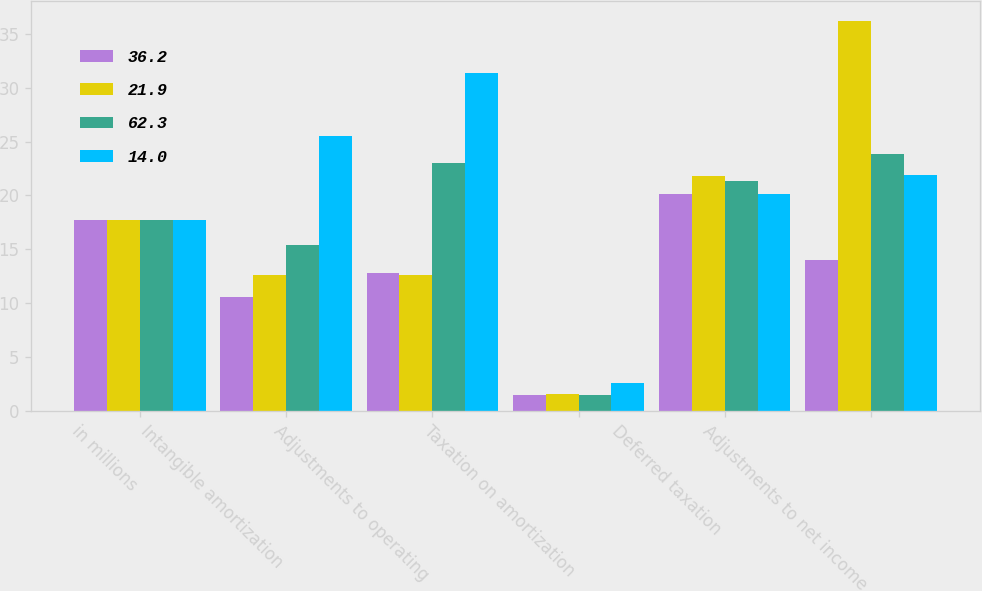Convert chart. <chart><loc_0><loc_0><loc_500><loc_500><stacked_bar_chart><ecel><fcel>in millions<fcel>Intangible amortization<fcel>Adjustments to operating<fcel>Taxation on amortization<fcel>Deferred taxation<fcel>Adjustments to net income<nl><fcel>36.2<fcel>17.75<fcel>10.6<fcel>12.8<fcel>1.5<fcel>20.1<fcel>14<nl><fcel>21.9<fcel>17.75<fcel>12.6<fcel>12.6<fcel>1.6<fcel>21.8<fcel>36.2<nl><fcel>62.3<fcel>17.75<fcel>15.4<fcel>23<fcel>1.5<fcel>21.3<fcel>23.8<nl><fcel>14<fcel>17.75<fcel>25.5<fcel>31.4<fcel>2.6<fcel>20.1<fcel>21.9<nl></chart> 